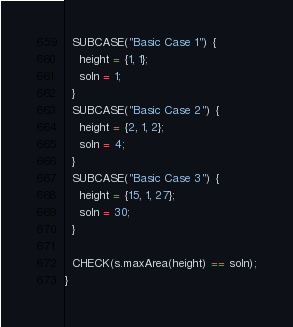Convert code to text. <code><loc_0><loc_0><loc_500><loc_500><_C++_>  SUBCASE("Basic Case 1") {
    height = {1, 1};
    soln = 1;
  }
  SUBCASE("Basic Case 2") {
    height = {2, 1, 2};
    soln = 4;
  }
  SUBCASE("Basic Case 3") {
    height = {15, 1, 27};
    soln = 30;
  }

  CHECK(s.maxArea(height) == soln);
}
</code> 